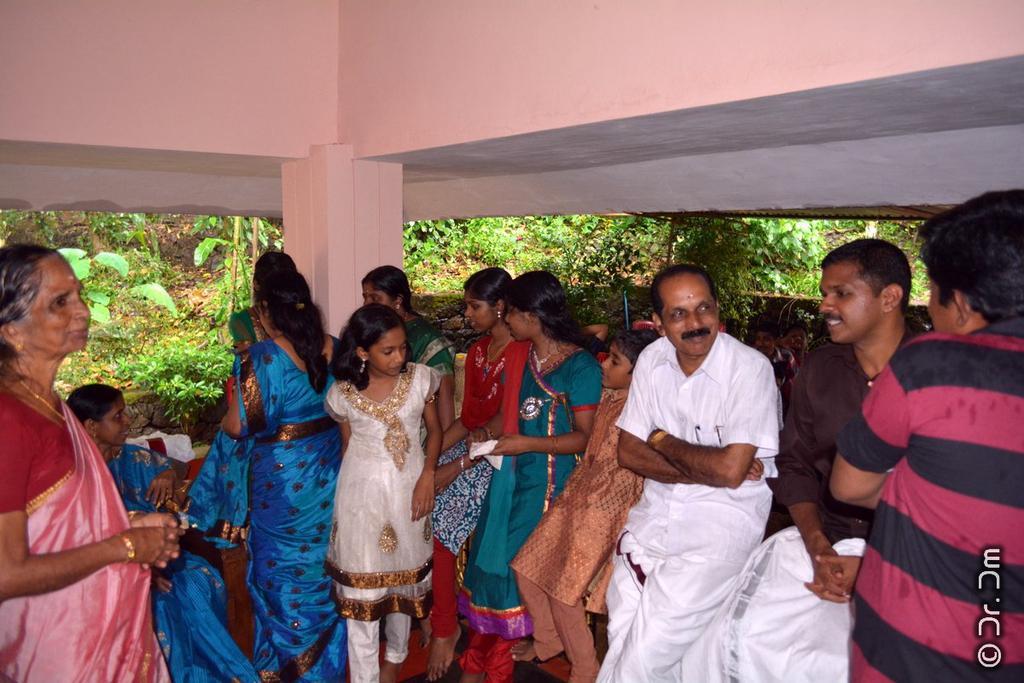In one or two sentences, can you explain what this image depicts? In this image there are group of people who are sitting on the wall. On the right side there are three men who are talking with each other. On the left side there are girls who are sitting on the wall. In the background there are small plants and trees. At the top there is the wall. 